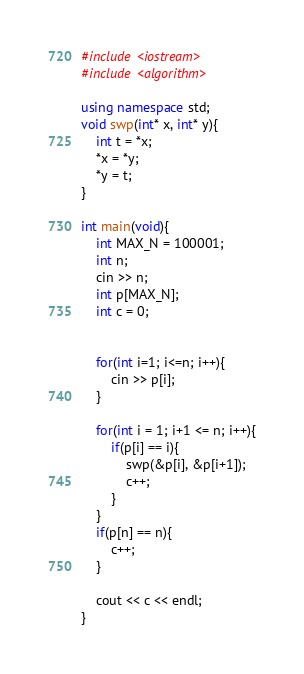<code> <loc_0><loc_0><loc_500><loc_500><_C++_>#include <iostream>
#include <algorithm>

using namespace std;
void swp(int* x, int* y){
    int t = *x;
    *x = *y;
    *y = t;
}

int main(void){
    int MAX_N = 100001;
    int n;
    cin >> n;
    int p[MAX_N];
    int c = 0;


    for(int i=1; i<=n; i++){
        cin >> p[i];
    }

    for(int i = 1; i+1 <= n; i++){
        if(p[i] == i){
            swp(&p[i], &p[i+1]);
            c++;
        }
    }
    if(p[n] == n){
        c++;
    }

    cout << c << endl;
}
</code> 